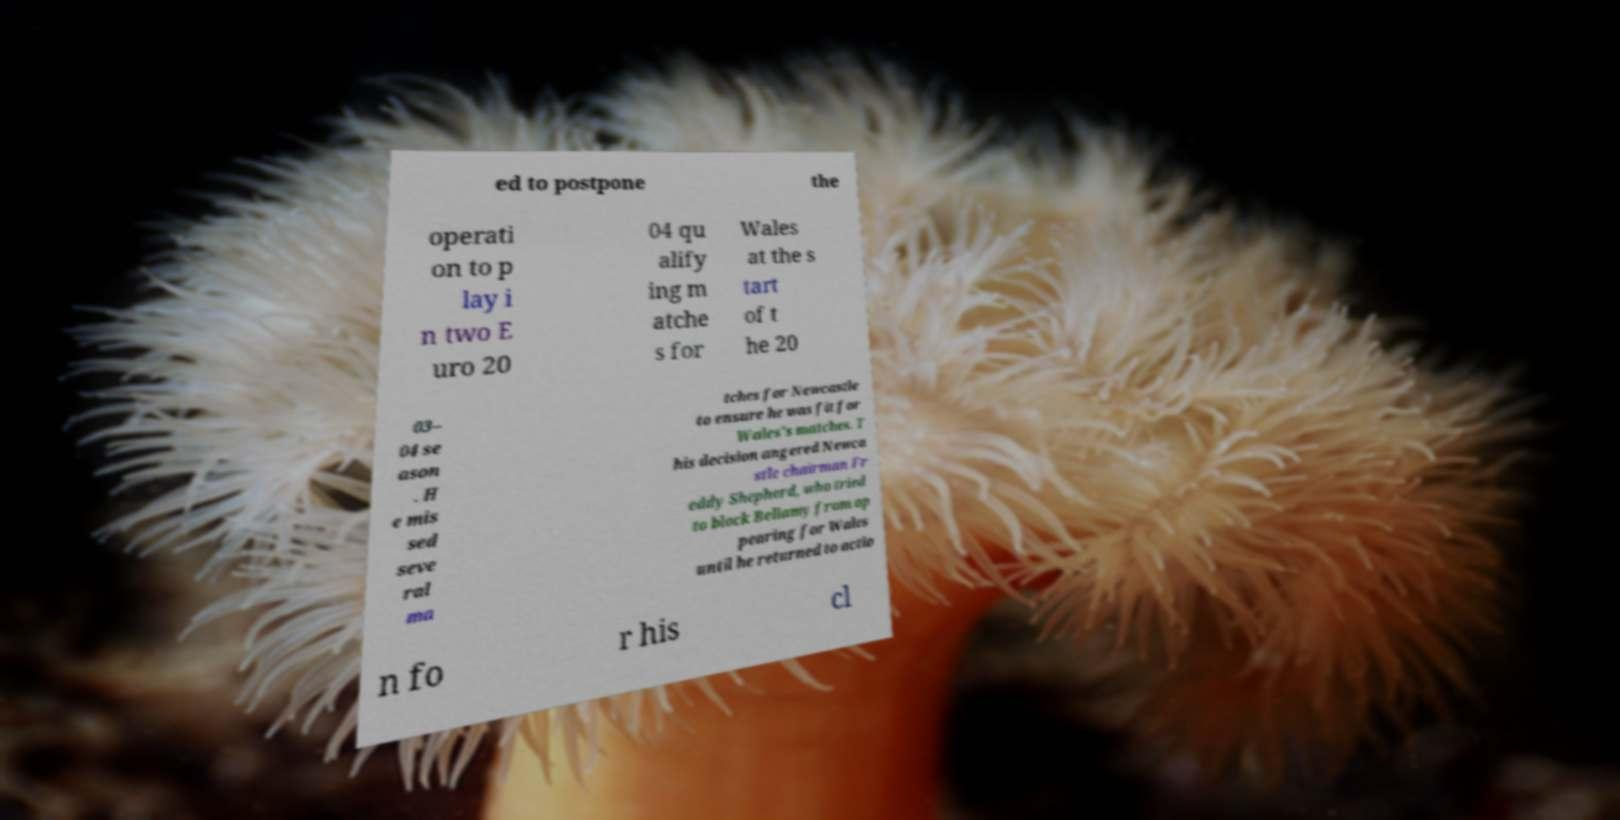Please read and relay the text visible in this image. What does it say? ed to postpone the operati on to p lay i n two E uro 20 04 qu alify ing m atche s for Wales at the s tart of t he 20 03– 04 se ason . H e mis sed seve ral ma tches for Newcastle to ensure he was fit for Wales's matches. T his decision angered Newca stle chairman Fr eddy Shepherd, who tried to block Bellamy from ap pearing for Wales until he returned to actio n fo r his cl 